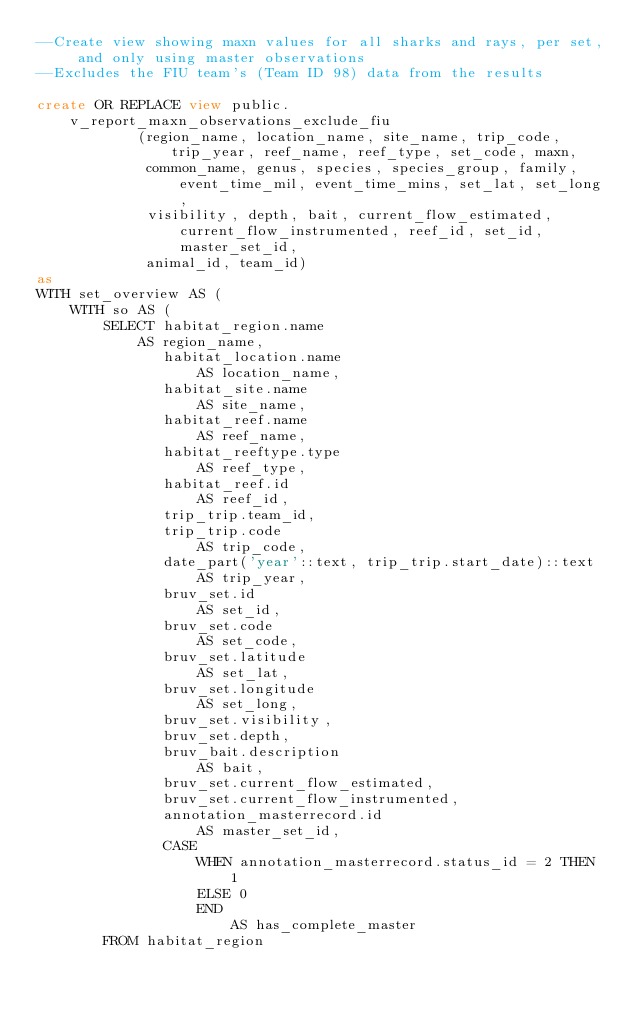Convert code to text. <code><loc_0><loc_0><loc_500><loc_500><_SQL_>--Create view showing maxn values for all sharks and rays, per set, and only using master observations
--Excludes the FIU team's (Team ID 98) data from the results

create OR REPLACE view public.v_report_maxn_observations_exclude_fiu
            (region_name, location_name, site_name, trip_code, trip_year, reef_name, reef_type, set_code, maxn,
             common_name, genus, species, species_group, family, event_time_mil, event_time_mins, set_lat, set_long,
             visibility, depth, bait, current_flow_estimated, current_flow_instrumented, reef_id, set_id, master_set_id,
             animal_id, team_id)
as
WITH set_overview AS (
    WITH so AS (
        SELECT habitat_region.name                                 AS region_name,
               habitat_location.name                               AS location_name,
               habitat_site.name                                   AS site_name,
               habitat_reef.name                                   AS reef_name,
               habitat_reeftype.type                               AS reef_type,
               habitat_reef.id                                     AS reef_id,
               trip_trip.team_id,
               trip_trip.code                                      AS trip_code,
               date_part('year'::text, trip_trip.start_date)::text AS trip_year,
               bruv_set.id                                         AS set_id,
               bruv_set.code                                       AS set_code,
               bruv_set.latitude                                   AS set_lat,
               bruv_set.longitude                                  AS set_long,
               bruv_set.visibility,
               bruv_set.depth,
               bruv_bait.description                               AS bait,
               bruv_set.current_flow_estimated,
               bruv_set.current_flow_instrumented,
               annotation_masterrecord.id                          AS master_set_id,
               CASE
                   WHEN annotation_masterrecord.status_id = 2 THEN 1
                   ELSE 0
                   END                                             AS has_complete_master
        FROM habitat_region</code> 